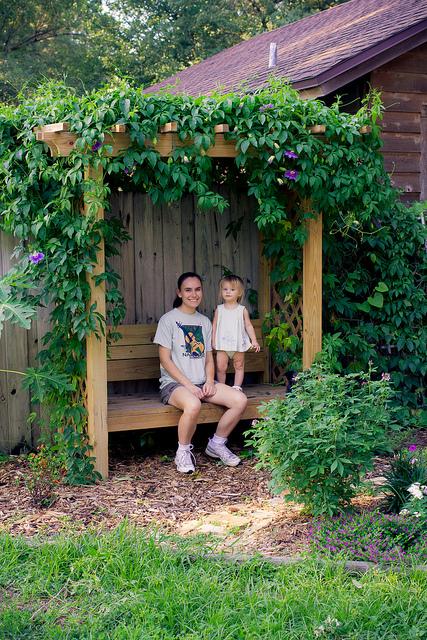What is behind the man seated?
Keep it brief. Wall. Is the child more than six years old?
Answer briefly. No. How many people are in the picture?
Keep it brief. 2. What is the woman sitting on?
Give a very brief answer. Bench. Is it raining outside?
Answer briefly. No. 